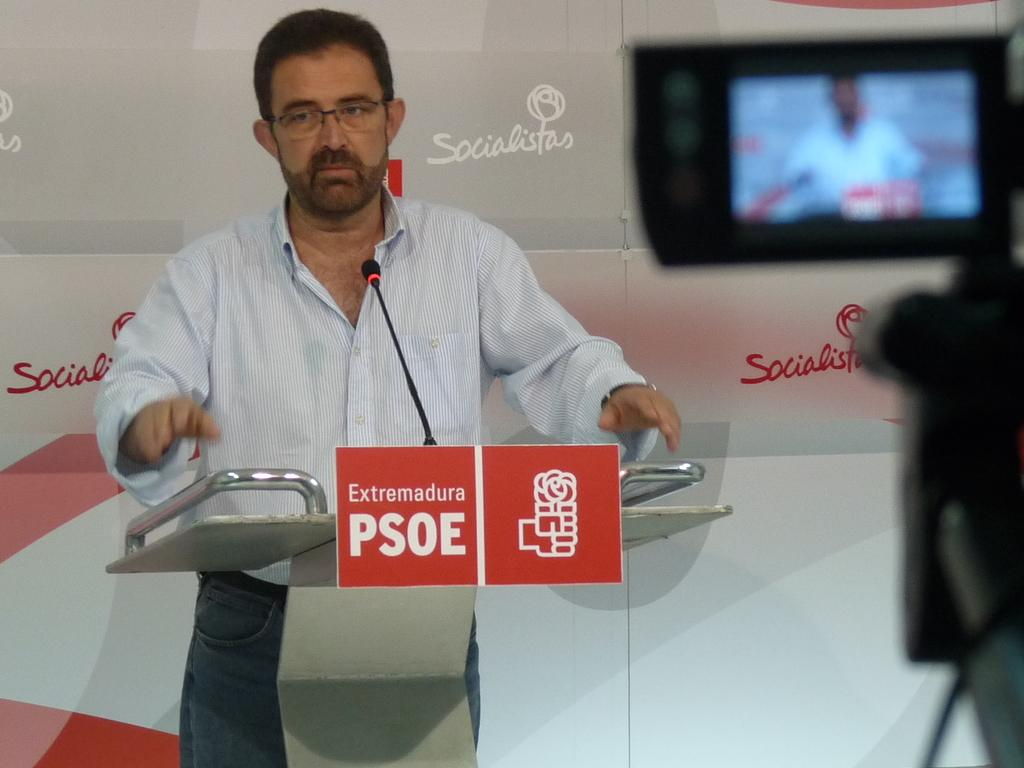What is the man in the image doing? The man is standing at the podium. What is on the podium with the man? There is a microphone and two small boards on the podium. What can be seen in the background of the image? There is a hoarding in the background. Where is the camera located in the image? The camera is on the right side of the image. What type of jeans is the man wearing in the image? The image does not provide information about the man's clothing, so it cannot be determined if he is wearing jeans or any other type of clothing. 